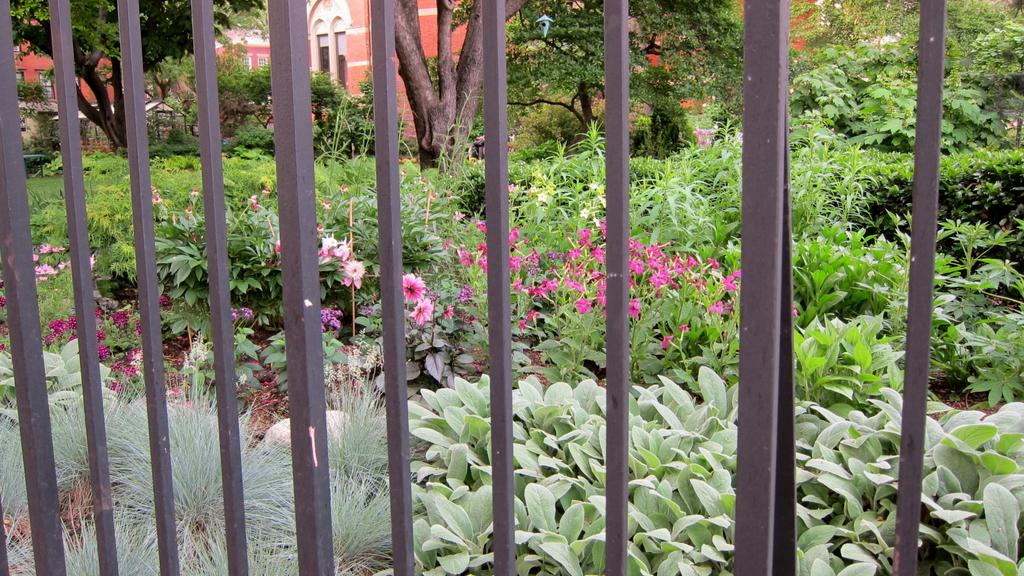What is the main structure in the center of the image? There is a building in the center of the image. What type of natural elements can be seen in the image? Trees, plants, grass, and flowers are visible in the image. Can you describe the foreground of the image? There is a grille in the foreground of the image. What type of bread is being served with a fork on the table in the image? There is no bread or fork present in the image; it features a building, trees, plants, grass, flowers, and a grille. Can you tell me how many cows are grazing in the grass in the image? There are no cows present in the image; it features a building, trees, plants, grass, flowers, and a grille. 